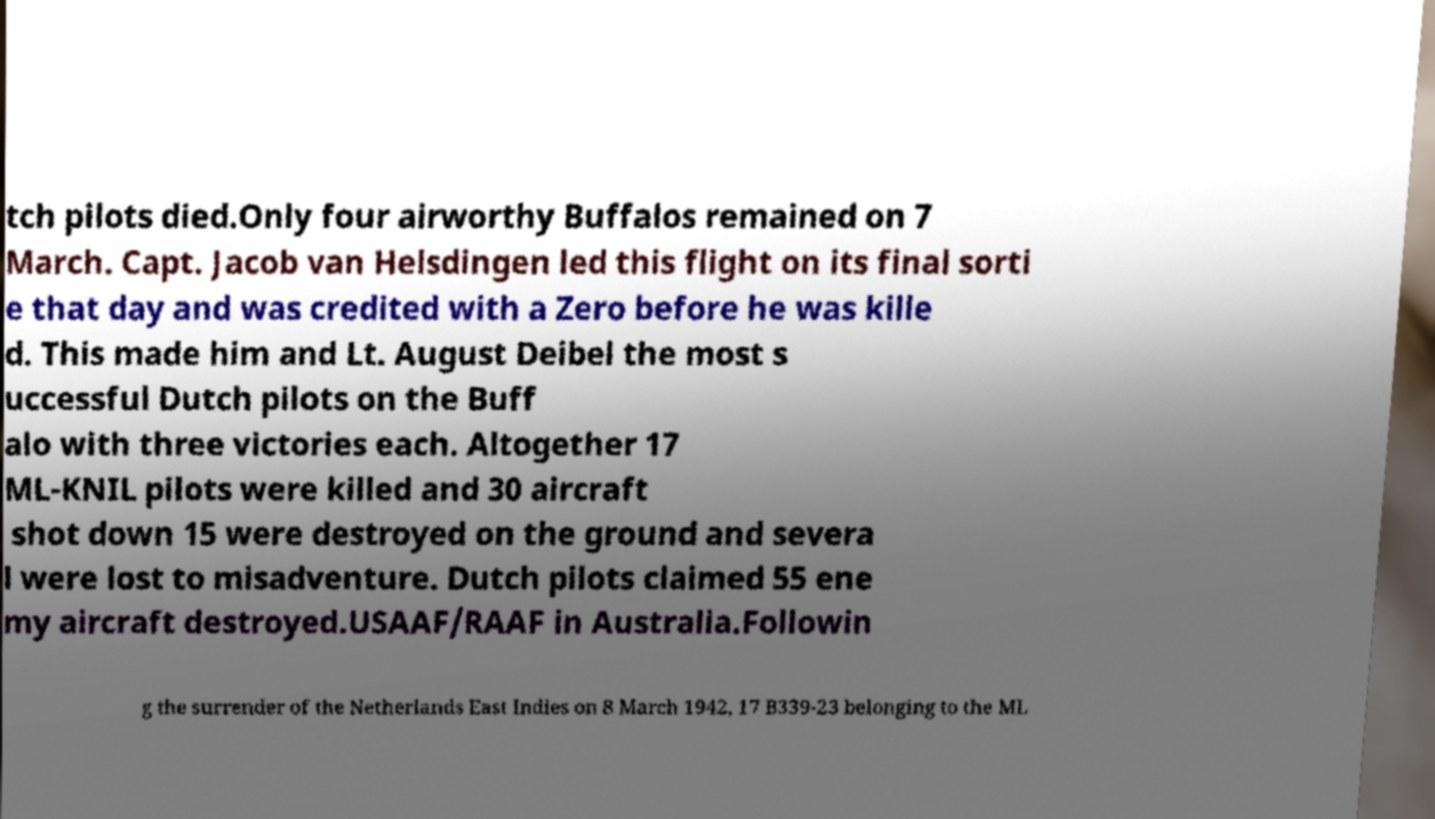Please read and relay the text visible in this image. What does it say? tch pilots died.Only four airworthy Buffalos remained on 7 March. Capt. Jacob van Helsdingen led this flight on its final sorti e that day and was credited with a Zero before he was kille d. This made him and Lt. August Deibel the most s uccessful Dutch pilots on the Buff alo with three victories each. Altogether 17 ML-KNIL pilots were killed and 30 aircraft shot down 15 were destroyed on the ground and severa l were lost to misadventure. Dutch pilots claimed 55 ene my aircraft destroyed.USAAF/RAAF in Australia.Followin g the surrender of the Netherlands East Indies on 8 March 1942, 17 B339-23 belonging to the ML 